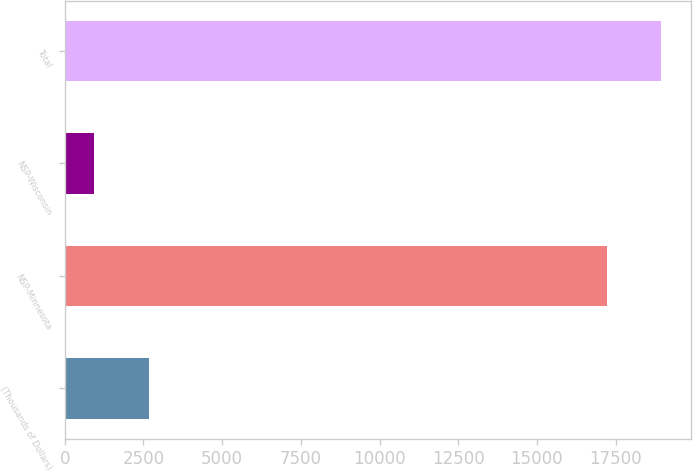<chart> <loc_0><loc_0><loc_500><loc_500><bar_chart><fcel>(Thousands of Dollars)<fcel>NSP-Minnesota<fcel>NSP-Wisconsin<fcel>Total<nl><fcel>2666.3<fcel>17223<fcel>944<fcel>18945.3<nl></chart> 